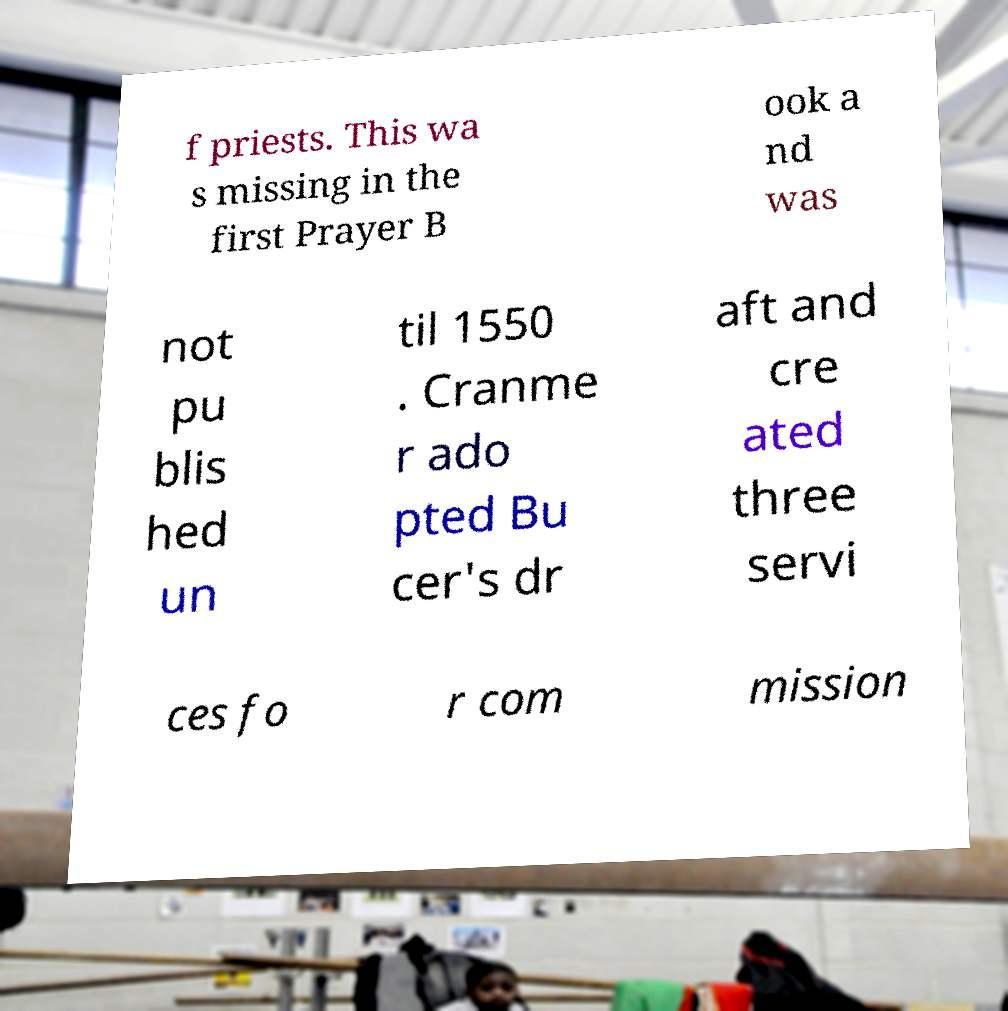Can you accurately transcribe the text from the provided image for me? f priests. This wa s missing in the first Prayer B ook a nd was not pu blis hed un til 1550 . Cranme r ado pted Bu cer's dr aft and cre ated three servi ces fo r com mission 